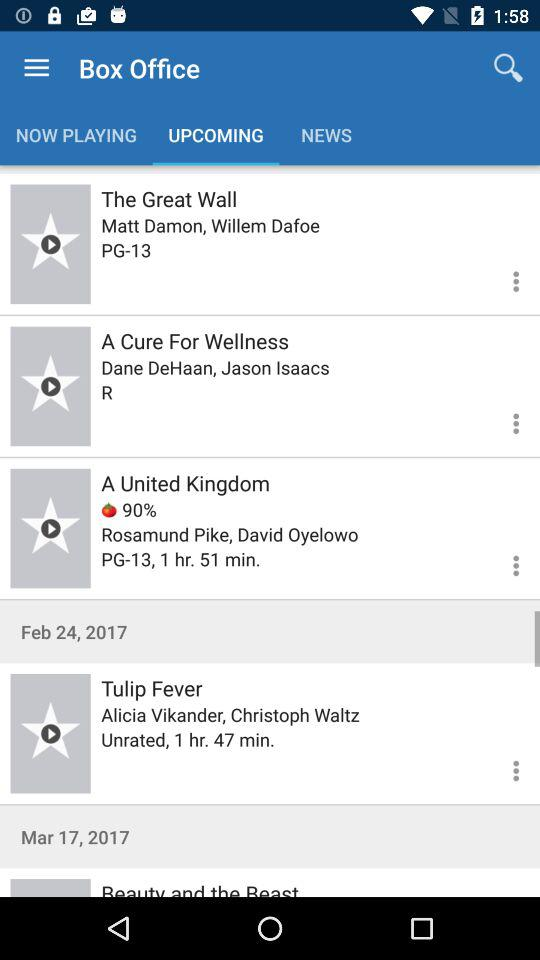How many of the movies have a rating of PG-13?
Answer the question using a single word or phrase. 2 